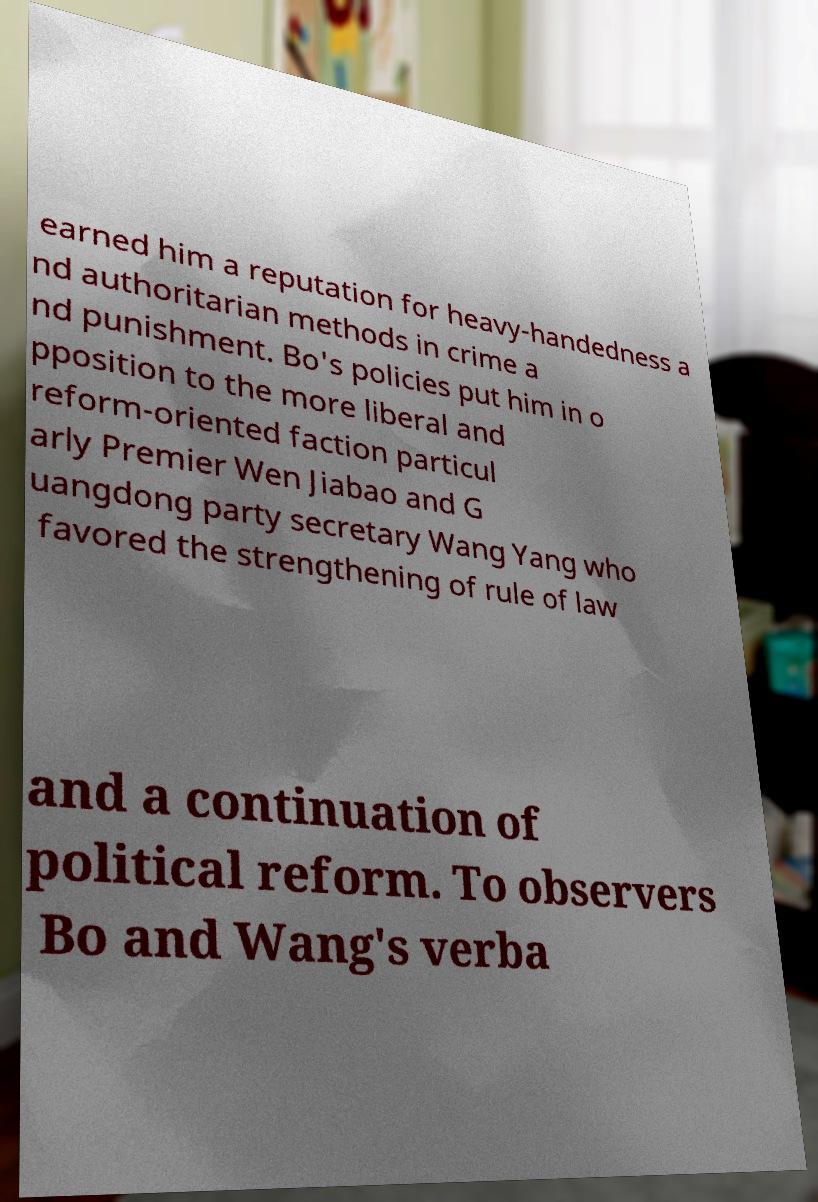Please identify and transcribe the text found in this image. earned him a reputation for heavy-handedness a nd authoritarian methods in crime a nd punishment. Bo's policies put him in o pposition to the more liberal and reform-oriented faction particul arly Premier Wen Jiabao and G uangdong party secretary Wang Yang who favored the strengthening of rule of law and a continuation of political reform. To observers Bo and Wang's verba 